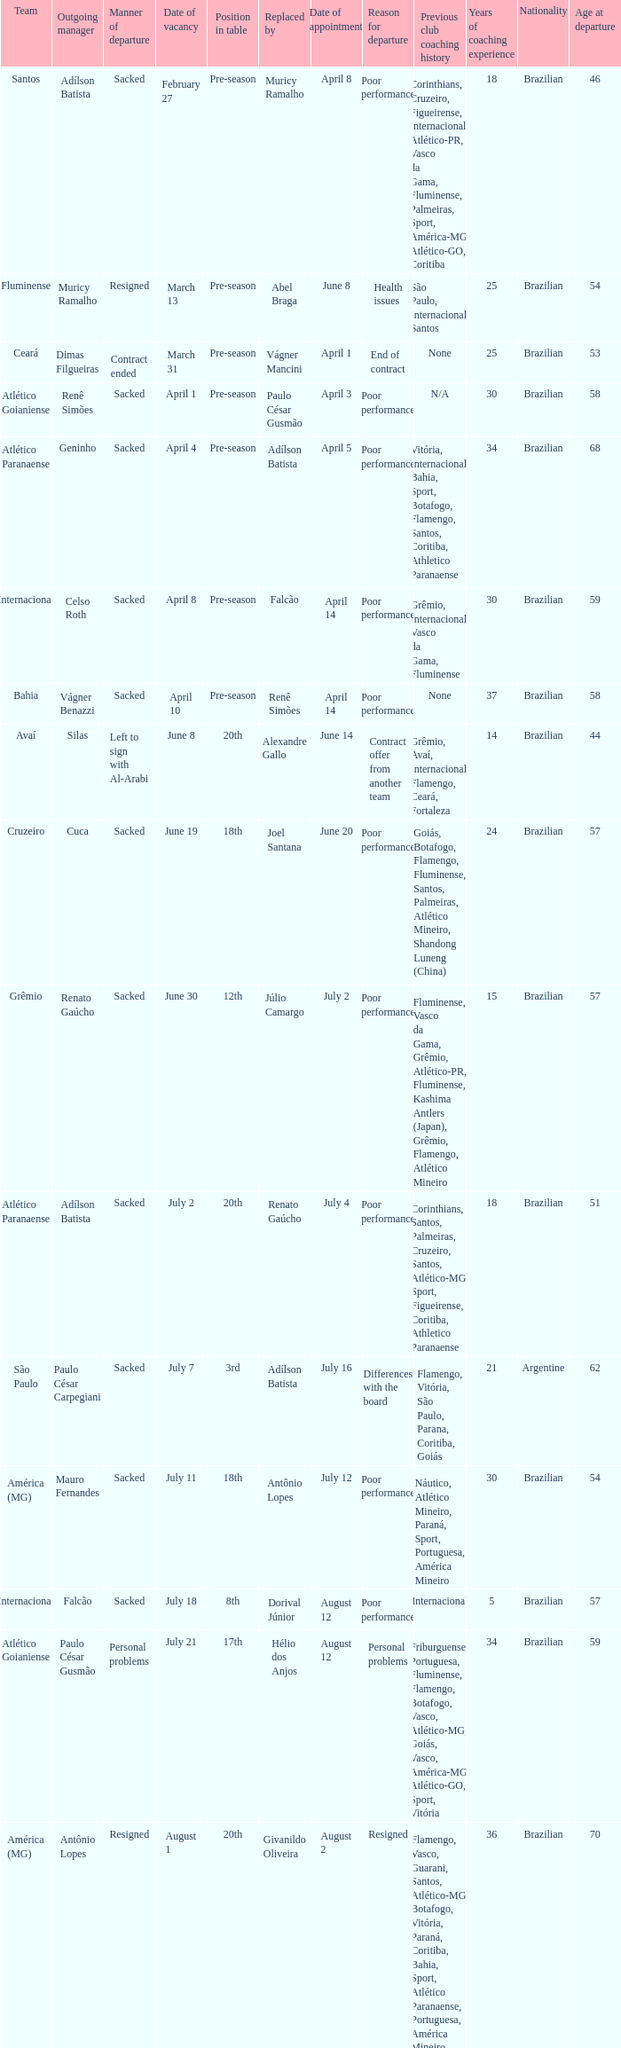Who was the new Santos manager? Muricy Ramalho. Would you mind parsing the complete table? {'header': ['Team', 'Outgoing manager', 'Manner of departure', 'Date of vacancy', 'Position in table', 'Replaced by', 'Date of appointment', 'Reason for departure', 'Previous club coaching history', 'Years of coaching experience', 'Nationality', 'Age at departure'], 'rows': [['Santos', 'Adílson Batista', 'Sacked', 'February 27', 'Pre-season', 'Muricy Ramalho', 'April 8', 'Poor performance', 'Corinthians, Cruzeiro, Figueirense, Internacional, Atlético-PR, Vasco da Gama, Fluminense, Palmeiras, Sport, América-MG, Atlético-GO, Coritiba', '18', 'Brazilian', '46'], ['Fluminense', 'Muricy Ramalho', 'Resigned', 'March 13', 'Pre-season', 'Abel Braga', 'June 8', 'Health issues', 'São Paulo, Internacional, Santos', '25', 'Brazilian', '54'], ['Ceará', 'Dimas Filgueiras', 'Contract ended', 'March 31', 'Pre-season', 'Vágner Mancini', 'April 1', 'End of contract', 'None', '25', 'Brazilian', '53'], ['Atlético Goianiense', 'Renê Simões', 'Sacked', 'April 1', 'Pre-season', 'Paulo César Gusmão', 'April 3', 'Poor performance', 'N/A', '30', 'Brazilian', '58'], ['Atlético Paranaense', 'Geninho', 'Sacked', 'April 4', 'Pre-season', 'Adílson Batista', 'April 5', 'Poor performance', 'Vitória, Internacional, Bahia, Sport, Botafogo, Flamengo, Santos, Coritiba, Athletico Paranaense', '34', 'Brazilian', '68'], ['Internacional', 'Celso Roth', 'Sacked', 'April 8', 'Pre-season', 'Falcão', 'April 14', 'Poor performance', 'Grêmio, Internacional, Vasco da Gama, Fluminense', '30', 'Brazilian', '59'], ['Bahia', 'Vágner Benazzi', 'Sacked', 'April 10', 'Pre-season', 'Renê Simões', 'April 14', 'Poor performance', 'None', '37', 'Brazilian', '58'], ['Avaí', 'Silas', 'Left to sign with Al-Arabi', 'June 8', '20th', 'Alexandre Gallo', 'June 14', 'Contract offer from another team', 'Grêmio, Avaí, Internacional, Flamengo, Ceará, Fortaleza', '14', 'Brazilian', '44'], ['Cruzeiro', 'Cuca', 'Sacked', 'June 19', '18th', 'Joel Santana', 'June 20', 'Poor performance', 'Goiás, Botafogo, Flamengo, Fluminense, Santos, Palmeiras, Atlético Mineiro, Shandong Luneng (China)', '24', 'Brazilian', '57'], ['Grêmio', 'Renato Gaúcho', 'Sacked', 'June 30', '12th', 'Júlio Camargo', 'July 2', 'Poor performance', 'Fluminense, Vasco da Gama, Grêmio, Atlético-PR, Fluminense, Kashima Antlers (Japan), Grêmio, Flamengo, Atlético Mineiro', '15', 'Brazilian', '57'], ['Atlético Paranaense', 'Adílson Batista', 'Sacked', 'July 2', '20th', 'Renato Gaúcho', 'July 4', 'Poor performance', 'Corinthians, Santos, Palmeiras, Cruzeiro, Santos, Atlético-MG, Sport, Figueirense, Coritiba, Athletico Paranaense', '18', 'Brazilian', '51'], ['São Paulo', 'Paulo César Carpegiani', 'Sacked', 'July 7', '3rd', 'Adílson Batista', 'July 16', 'Differences with the board', 'Flamengo, Vitória, São Paulo, Parana, Coritiba, Goiás', '21', 'Argentine', '62'], ['América (MG)', 'Mauro Fernandes', 'Sacked', 'July 11', '18th', 'Antônio Lopes', 'July 12', 'Poor performance', 'Náutico, Atlético Mineiro, Paraná, Sport, Portuguesa, América Mineiro', '30', 'Brazilian', '54'], ['Internacional', 'Falcão', 'Sacked', 'July 18', '8th', 'Dorival Júnior', 'August 12', 'Poor performance', 'Internacional', '5', 'Brazilian', '57'], ['Atlético Goianiense', 'Paulo César Gusmão', 'Personal problems', 'July 21', '17th', 'Hélio dos Anjos', 'August 12', 'Personal problems', 'Friburguense, Portuguesa, Fluminense, Flamengo, Botafogo, Vasco, Atlético-MG, Goiás, Vasco, América-MG, Atlético-GO, Sport, Vitória', '34', 'Brazilian', '59'], ['América (MG)', 'Antônio Lopes', 'Resigned', 'August 1', '20th', 'Givanildo Oliveira', 'August 2', 'Resigned', 'Flamengo, Vasco, Guarani, Santos, Atlético-MG, Botafogo, Vitória, Paraná, Coritiba, Bahia, Sport, Atlético Paranaense, Portuguesa, América Mineiro, Brasil de Pelotas', '36', 'Brazilian', '70'], ['Grêmio', 'Júlio Camargo', 'Sacked', 'August 4', '15th', 'Celso Roth', 'August 4', 'Poor performance', 'N/A', '15', 'Brazilian', '48'], ['Atlético Mineiro', 'Dorival Júnior', 'Sacked', 'August 7', '14th', 'Cuca', 'August 8', 'Poor performance', 'Botafogo, Santos, Internacional, Vasco da Gama, Atlético Mineiro, Flamengo, Palmeiras, Fluminense', '19', 'Brazilian', '59'], ['Avaí', 'Alexandre Gallo', 'Sacked', 'August 18', '19th', 'Toninho Cecílio', 'August 22', 'Poor performance', 'São Caetano, Sport, Náutico, Atlético-MG, Vitória, Avaí, Vitória, Santa Cruz, Ponte Preta, Figueirense', '16', 'Brazilian', '52'], ['Vasco da Gama', 'Ricardo Gomes', 'Health problems (temporarily)', 'August 28', '4th', 'Cristóvão Borges ( caretaker )', 'August 29', 'Health problems', 'São Caetano, Guarani, Paysandu, Vasco, Botafogo, São Paulo, Figueirense', '26', 'Brazilian', '46'], ['Atlético Paranaense', 'Renato Gaúcho', 'Resigned', 'September 1', '19th', 'Antônio Lopes', 'September 1', 'Personal reasons', 'Fluminense, Vasco da Gama, Grêmio, Atlético Paranaense, Fluminense, Shandong Luneng (China), Flamengo', '15', 'Brazilian', '57'], ['Cruzeiro', 'Joel Santana', 'Sacked', 'September 2', '11th', 'Emerson Ávila', 'September 2', 'Poor performance', 'Vasco da Gama, Flamengo, Botafogo, Fluminense, Vila Nova, São Caetano, Brasiliense, Bahia, Avaí, Cruzeiro', '30', 'Brazilian', '71'], ['Bahia', 'René Simões', 'Sacked', 'September 2', '16th', 'Joel Santana', 'September 4', 'Poor performance', 'Santa Cruz, Tokyo Verdy (Japan), Botafogo, Figueirense, Vitória, Coritiba, Goiás, Fluminense, Atlético-GO, Paraná, Jamaica, Avaí, Remo, Boavista', '35', 'Brazilian', '67'], ['Ceará', 'Vágner Mancini', 'Sacked', 'September 11', '15th', 'Estevam Soares', 'September 14', 'Poor performance', 'Grêmio, Santos, Vasco da Gama, Vitória, Cruzeiro, São Paulo, Sport, Chapecoense, Botafogo, Vitória, Ceará, Atlético-MG, Atlético-PR, Vitória', '20', 'Brazilian', '53'], ['Cruzeiro', 'Emerson Ávila', 'Sacked', 'September 26', '16th', 'Vágner Mancini', 'September 26', 'Poor performance', 'Cruzeiro (youth), Atlético-MG (youth), Juventude, Paraná Clube, Cruzeiro (assistant), Seleção Brasileira sub-15, Desportiva-ES, Joinville, Avaí, Flamengo (assistant), Cruzeiro (interim), América-MG (youth), Tupi, Bahia, América-MG, Cruzeiro (interim), Chapecoense', '27', 'Brazilian', '52'], ['São Paulo', 'Adílson Batista', 'Sacked', 'October 16', '6th', 'Émerson Leão', 'October 24', 'Poor performance', 'Cruzeiro, Corinthians, Figueirense, Grêmio, Santos, Atlético-PR, Vasco, Sport, Atlético-MG, Ceará, Atlético-GO, Avaí, Joinville', '21', 'Brazilian', '53'], ['Ceará', 'Estevam Soares', 'Sacked', 'October 23', '17th', 'Dimas Filgueiras', 'October 24', 'Poor performance', 'Portuguesa, Paraná, Fluminense, Atlético-GO, CRB, Paulista, Sport, Inter de Limeira, Vila Nova, Ituano, Paraná, Náutico, Ceará', '23', 'Brazilian', '62'], ['Avaí', 'Toninho Cecílio', 'Sacked', 'November 14', '20th', 'Edson Neguinho ( caretaker )', 'November 14', 'Poor performance', 'Ferroviária, Fluminense, Alverca (Portugal), Flamengo, Juventude, Portuguesa Santista, Inter de Limeira, Paraná Clube, Coritiba, Bragantino, Botafogo-SP, América-SP, Bahia, Yeungnam University (South Korea), Avaí, CRB, Arapongas, Treze, Noroeste, Rio Branco-PR, Penapolense', '29', 'Brazilian', '50']]} 